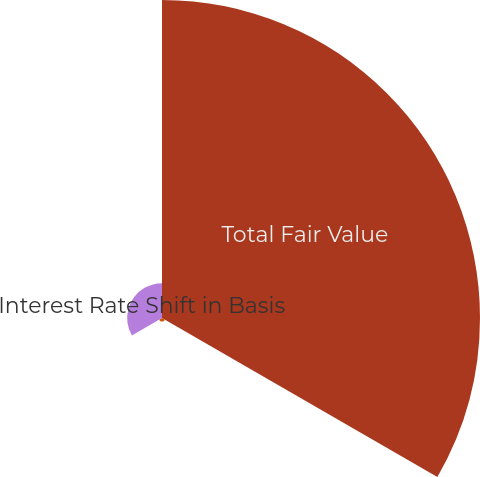<chart> <loc_0><loc_0><loc_500><loc_500><pie_chart><fcel>Total Fair Value<fcel>Fair Value Change from Base ()<fcel>Interest Rate Shift in Basis<nl><fcel>89.28%<fcel>0.94%<fcel>9.78%<nl></chart> 